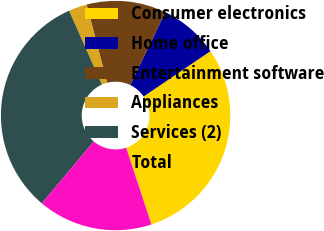Convert chart. <chart><loc_0><loc_0><loc_500><loc_500><pie_chart><fcel>Consumer electronics<fcel>Home office<fcel>Entertainment software<fcel>Appliances<fcel>Services (2)<fcel>Total<nl><fcel>29.43%<fcel>8.38%<fcel>11.19%<fcel>2.59%<fcel>32.24%<fcel>16.17%<nl></chart> 